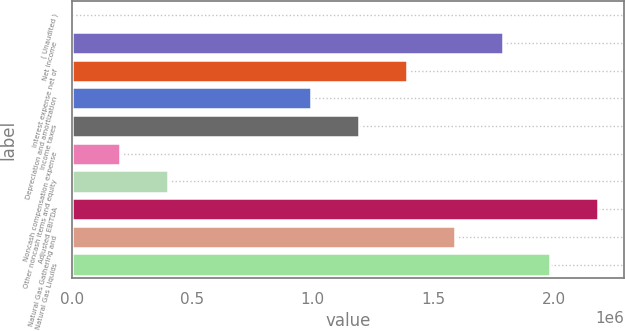Convert chart to OTSL. <chart><loc_0><loc_0><loc_500><loc_500><bar_chart><fcel>( Unaudited )<fcel>Net income<fcel>Interest expense net of<fcel>Depreciation and amortization<fcel>Income taxes<fcel>Noncash compensation expense<fcel>Other noncash items and equity<fcel>Adjusted EBITDA<fcel>Natural Gas Gathering and<fcel>Natural Gas Liquids<nl><fcel>2017<fcel>1.78837e+06<fcel>1.3914e+06<fcel>994435<fcel>1.19292e+06<fcel>200501<fcel>398984<fcel>2.18534e+06<fcel>1.58989e+06<fcel>1.98685e+06<nl></chart> 